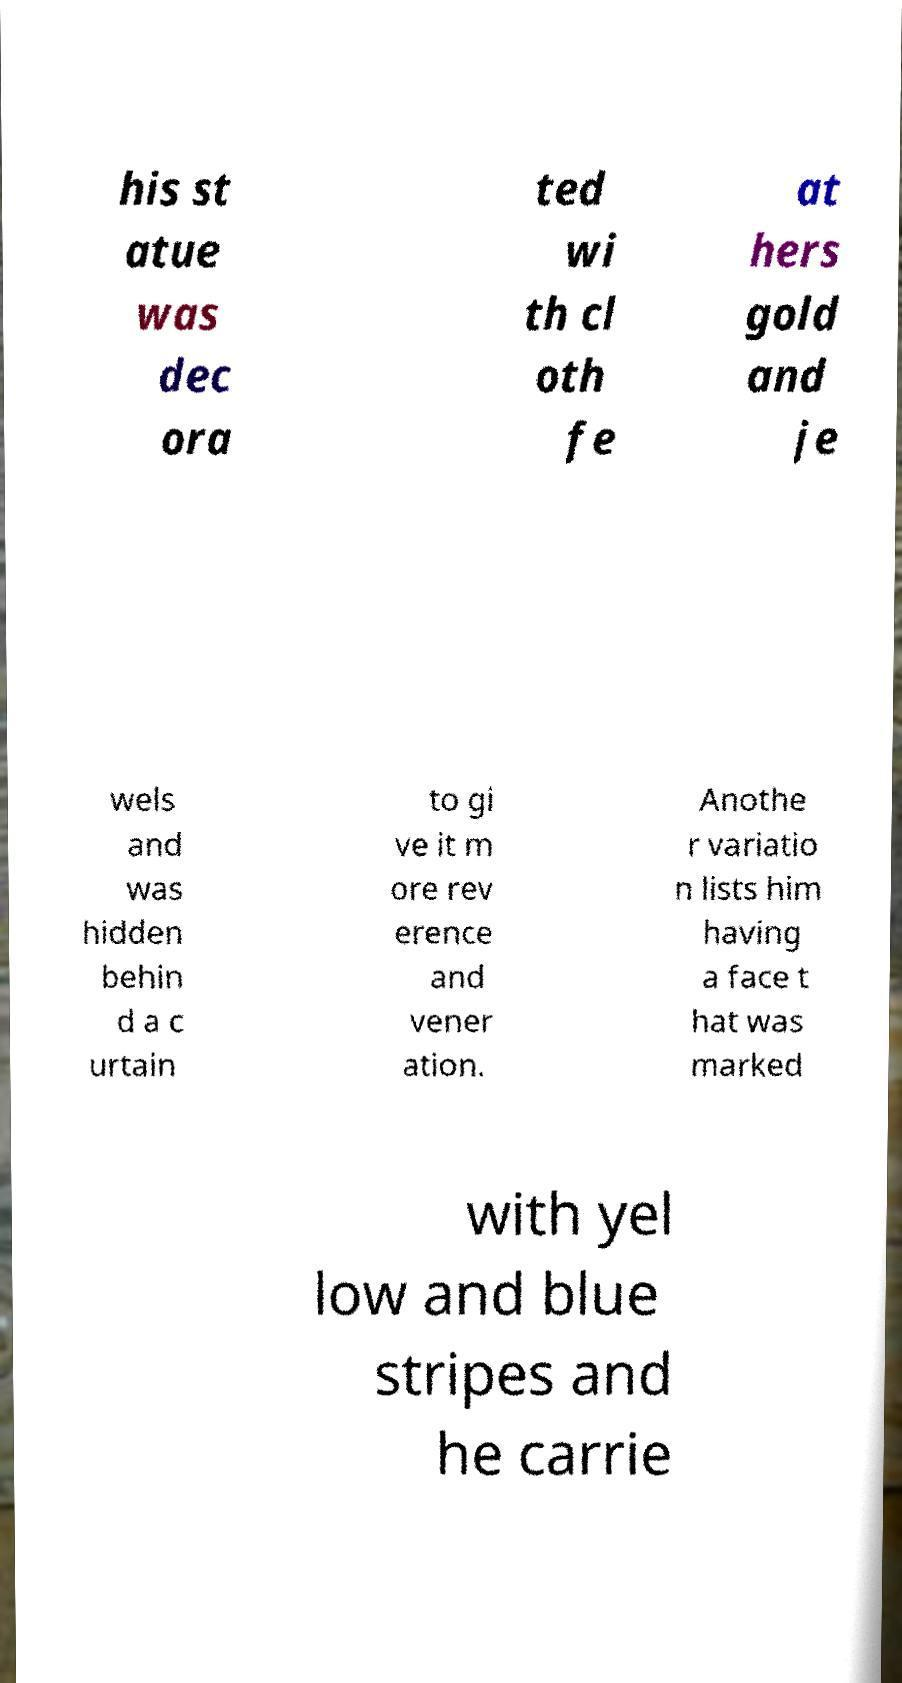Please identify and transcribe the text found in this image. his st atue was dec ora ted wi th cl oth fe at hers gold and je wels and was hidden behin d a c urtain to gi ve it m ore rev erence and vener ation. Anothe r variatio n lists him having a face t hat was marked with yel low and blue stripes and he carrie 